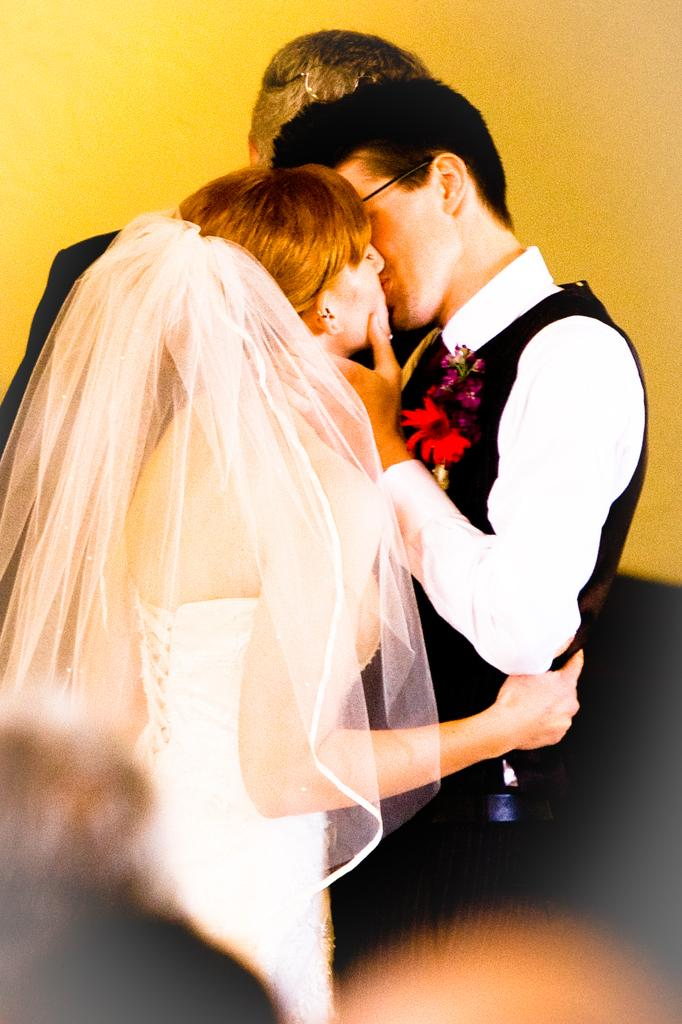Who is the main subject in the image? The main subjects in the image are the groom and the bride. What is the groom wearing in the image? The groom is wearing a black suit in the image. What is the bride wearing in the image? The bride is wearing a white gown in the image. What are the bride and groom doing in the image? The bride and groom are kissing each other in the image. What is the color of the background in the image? The background in the image is yellow. What is the reaction of the bride's family to the groom's wealth in the image? There is no information about the bride's family or the groom's wealth in the image, so it is not possible to determine their reaction. 